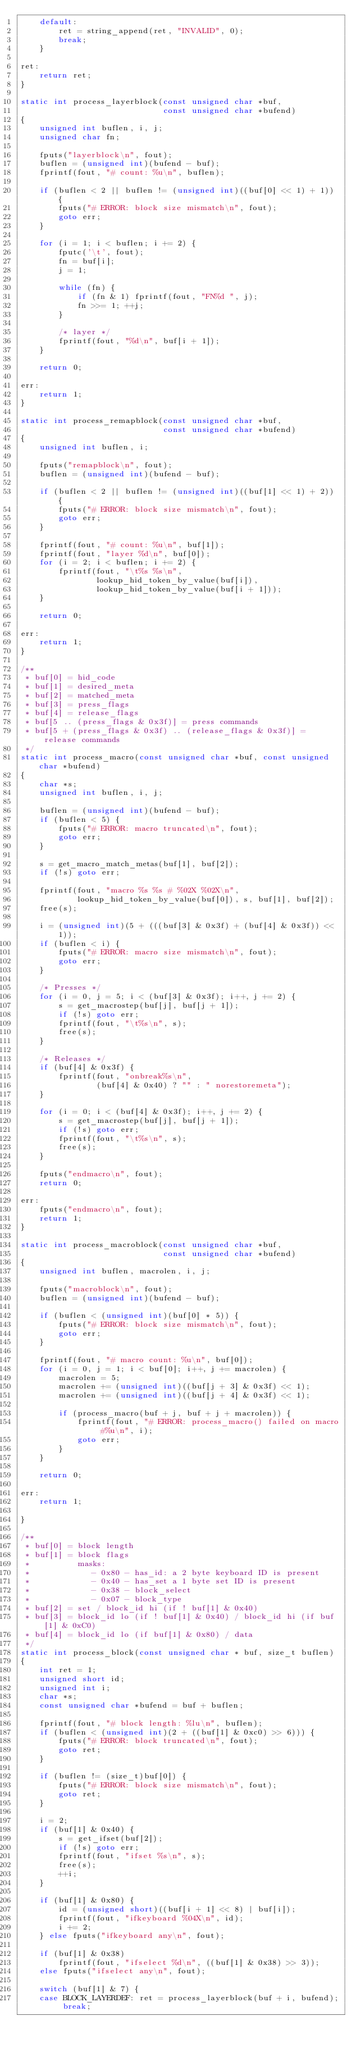Convert code to text. <code><loc_0><loc_0><loc_500><loc_500><_C_>	default:
		ret = string_append(ret, "INVALID", 0);
		break;
	}

ret:
	return ret;
}

static int process_layerblock(const unsigned char *buf,
                              const unsigned char *bufend)
{
	unsigned int buflen, i, j;
	unsigned char fn;

	fputs("layerblock\n", fout);
	buflen = (unsigned int)(bufend - buf);
	fprintf(fout, "# count: %u\n", buflen);

	if (buflen < 2 || buflen != (unsigned int)((buf[0] << 1) + 1)) {
		fputs("# ERROR: block size mismatch\n", fout);
		goto err;
	}

	for (i = 1; i < buflen; i += 2) {
		fputc('\t', fout);
		fn = buf[i];
		j = 1;

		while (fn) {
			if (fn & 1) fprintf(fout, "FN%d ", j);
			fn >>= 1; ++j;
		}

		/* layer */
		fprintf(fout, "%d\n", buf[i + 1]);
	}

	return 0;

err:
	return 1;
}

static int process_remapblock(const unsigned char *buf,
                              const unsigned char *bufend)
{
	unsigned int buflen, i;

	fputs("remapblock\n", fout);
	buflen = (unsigned int)(bufend - buf);

	if (buflen < 2 || buflen != (unsigned int)((buf[1] << 1) + 2)) {
		fputs("# ERROR: block size mismatch\n", fout);
		goto err;
	}

	fprintf(fout, "# count: %u\n", buf[1]);
	fprintf(fout, "layer %d\n", buf[0]);
	for (i = 2; i < buflen; i += 2) {
		fprintf(fout, "\t%s %s\n",
		        lookup_hid_token_by_value(buf[i]),
		        lookup_hid_token_by_value(buf[i + 1]));
	}

	return 0;

err:
	return 1;
}

/**
 * buf[0] = hid_code
 * buf[1] = desired_meta
 * buf[2] = matched_meta
 * buf[3] = press_flags
 * buf[4] = release_flags
 * buf[5 .. (press_flags & 0x3f)] = press commands
 * buf[5 + (press_flags & 0x3f) .. (release_flags & 0x3f)] = release commands
 */
static int process_macro(const unsigned char *buf, const unsigned char *bufend)
{
	char *s;
	unsigned int buflen, i, j;

	buflen = (unsigned int)(bufend - buf);
	if (buflen < 5) {
		fputs("# ERROR: macro truncated\n", fout);
		goto err;
	}

	s = get_macro_match_metas(buf[1], buf[2]);
	if (!s) goto err;

	fprintf(fout, "macro %s %s # %02X %02X\n",
	        lookup_hid_token_by_value(buf[0]), s, buf[1], buf[2]);
	free(s);

	i = (unsigned int)(5 + (((buf[3] & 0x3f) + (buf[4] & 0x3f)) << 1));
	if (buflen < i) {
		fputs("# ERROR: macro size mismatch\n", fout);
		goto err;
	}

	/* Presses */
	for (i = 0, j = 5; i < (buf[3] & 0x3f); i++, j += 2) {
		s = get_macrostep(buf[j], buf[j + 1]);
		if (!s) goto err;
		fprintf(fout, "\t%s\n", s);
		free(s);
	}

	/* Releases */
	if (buf[4] & 0x3f) {
		fprintf(fout, "onbreak%s\n",
		        (buf[4] & 0x40) ? "" : " norestoremeta");
	}

	for (i = 0; i < (buf[4] & 0x3f); i++, j += 2) {
		s = get_macrostep(buf[j], buf[j + 1]);
		if (!s) goto err;
		fprintf(fout, "\t%s\n", s);
		free(s);
	}

	fputs("endmacro\n", fout);
	return 0;

err:
	fputs("endmacro\n", fout);
	return 1;
}

static int process_macroblock(const unsigned char *buf,
                              const unsigned char *bufend)
{
	unsigned int buflen, macrolen, i, j;

	fputs("macroblock\n", fout);
	buflen = (unsigned int)(bufend - buf);

	if (buflen < (unsigned int)(buf[0] * 5)) {
		fputs("# ERROR: block size mismatch\n", fout);
		goto err;
	}

	fprintf(fout, "# macro count: %u\n", buf[0]);
	for (i = 0, j = 1; i < buf[0]; i++, j += macrolen) {
		macrolen = 5;
		macrolen += (unsigned int)((buf[j + 3] & 0x3f) << 1);
		macrolen += (unsigned int)((buf[j + 4] & 0x3f) << 1);

		if (process_macro(buf + j, buf + j + macrolen)) {
			fprintf(fout, "# ERROR: process_macro() failed on macro #%u\n", i);
			goto err;
		}
	}

	return 0;

err:
	return 1;

}

/**
 * buf[0] = block length
 * buf[1] = block flags
 *          masks:
 *             - 0x80 - has_id: a 2 byte keyboard ID is present
 *             - 0x40 - has_set a 1 byte set ID is present
 *             - 0x38 - block_select
 *             - 0x07 - block_type
 * buf[2] = set / block_id hi (if ! buf[1] & 0x40)
 * buf[3] = block_id lo (if ! buf[1] & 0x40) / block_id hi (if buf[1] & 0xC0)
 * buf[4] = block_id lo (if buf[1] & 0x80) / data
 */
static int process_block(const unsigned char * buf, size_t buflen)
{
	int ret = 1;
	unsigned short id;
	unsigned int i;
	char *s;
	const unsigned char *bufend = buf + buflen;

	fprintf(fout, "# block length: %lu\n", buflen);
	if (buflen < (unsigned int)(2 + ((buf[1] & 0xc0) >> 6))) {
		fputs("# ERROR: block truncated\n", fout);
		goto ret;
	}

	if (buflen != (size_t)buf[0]) {
		fputs("# ERROR: block size mismatch\n", fout);
		goto ret;
	}

	i = 2;
	if (buf[1] & 0x40) {
		s = get_ifset(buf[2]);
		if (!s) goto err;
		fprintf(fout, "ifset %s\n", s);
		free(s);
		++i;
	}

	if (buf[1] & 0x80) {
		id = (unsigned short)((buf[i + 1] << 8) | buf[i]);
		fprintf(fout, "ifkeyboard %04X\n", id);
		i += 2;
	} else fputs("ifkeyboard any\n", fout);

	if (buf[1] & 0x38)
		fprintf(fout, "ifselect %d\n", ((buf[1] & 0x38) >> 3));
	else fputs("ifselect any\n", fout);

	switch (buf[1] & 7) {
	case BLOCK_LAYERDEF: ret = process_layerblock(buf + i, bufend); break;</code> 